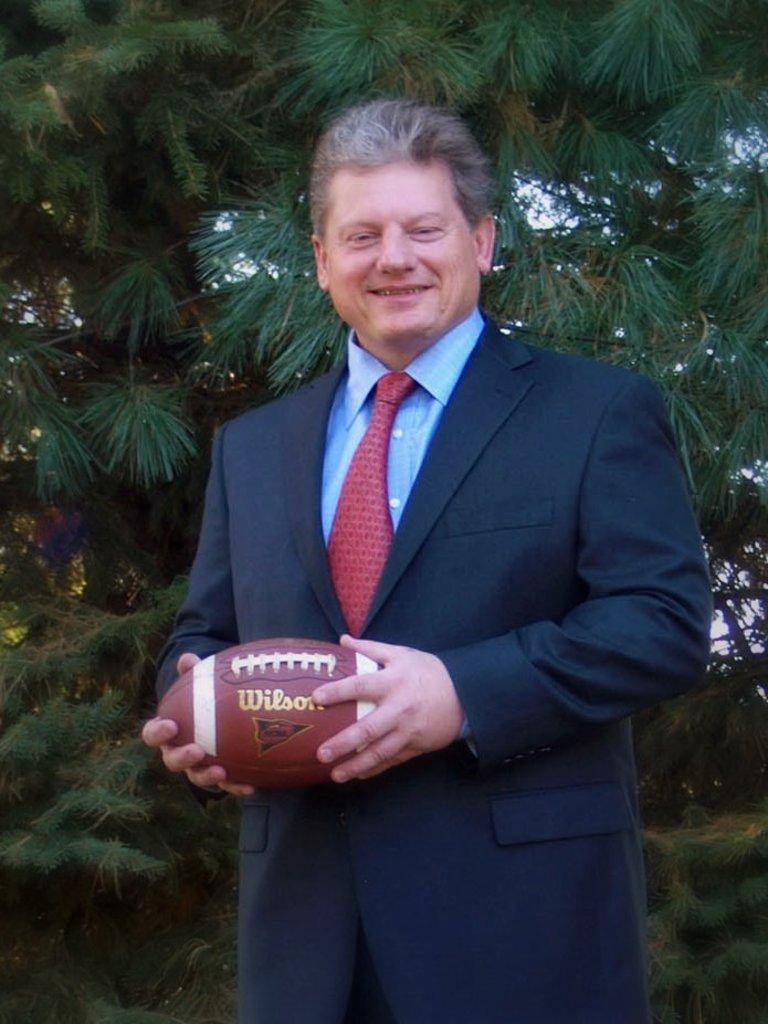What is the main subject of the image? The main subject of the image is a man. What is the man wearing? The man is wearing a black jacket, a blue shirt, and a tie. What is the man holding in his hand? The man is holding a baseball in his hand. What is the man's facial expression? The man is smiling. What can be seen in the background of the image? There is a tree behind the man. What type of secretary is sitting behind the man in the image? There is no secretary present in the image; it only features a man holding a baseball and a tree in the background. What key is the man using to unlock the door in the image? There is no door or key present in the image; the man is holding a baseball and standing in front of a tree. 